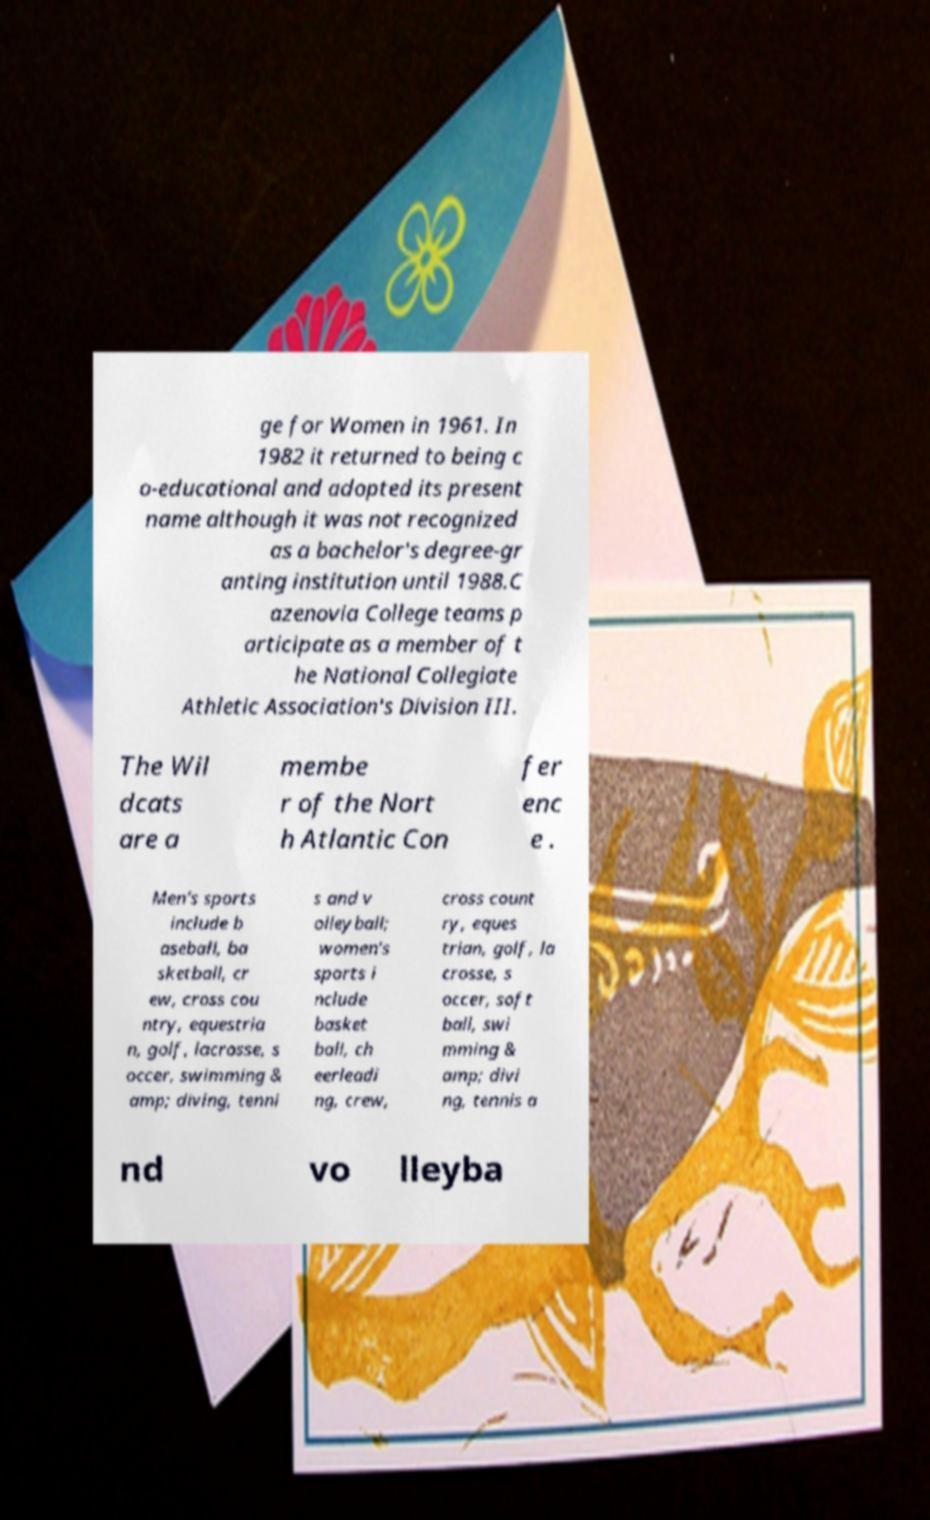What messages or text are displayed in this image? I need them in a readable, typed format. ge for Women in 1961. In 1982 it returned to being c o-educational and adopted its present name although it was not recognized as a bachelor's degree-gr anting institution until 1988.C azenovia College teams p articipate as a member of t he National Collegiate Athletic Association's Division III. The Wil dcats are a membe r of the Nort h Atlantic Con fer enc e . Men's sports include b aseball, ba sketball, cr ew, cross cou ntry, equestria n, golf, lacrosse, s occer, swimming & amp; diving, tenni s and v olleyball; women's sports i nclude basket ball, ch eerleadi ng, crew, cross count ry, eques trian, golf, la crosse, s occer, soft ball, swi mming & amp; divi ng, tennis a nd vo lleyba 